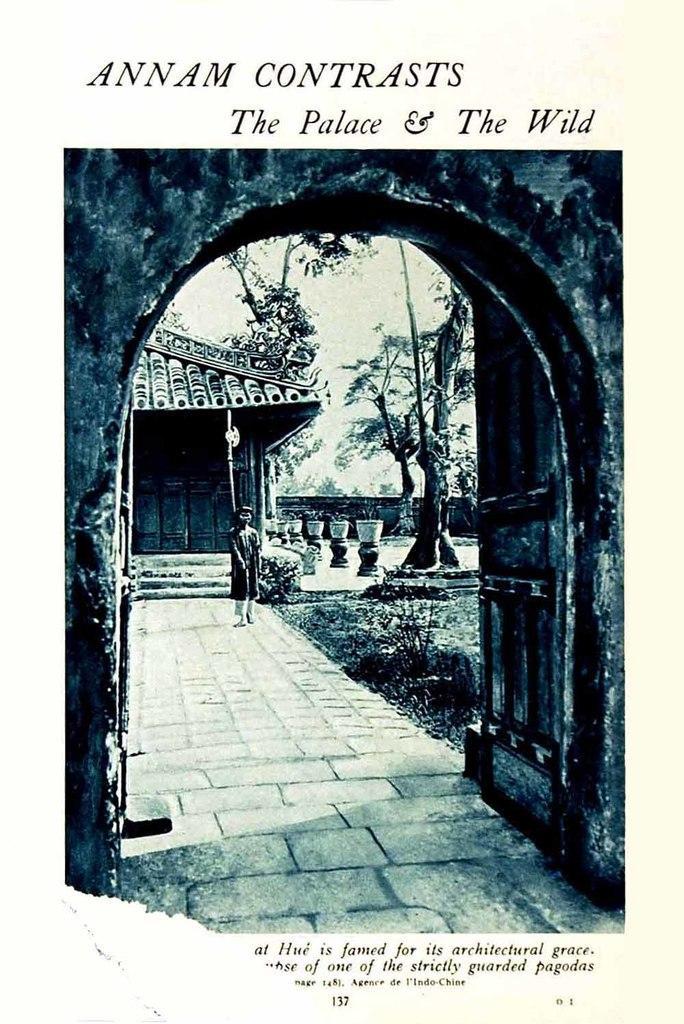Describe this image in one or two sentences. This is a poster. In this poster, we see an arch. In the middle of the poster, we see a girl is standing. Behind her, we see a staircase and a building with a roof. Beside her, we see plants, trees and pots. At the top of the poster, we see some text written on it. 